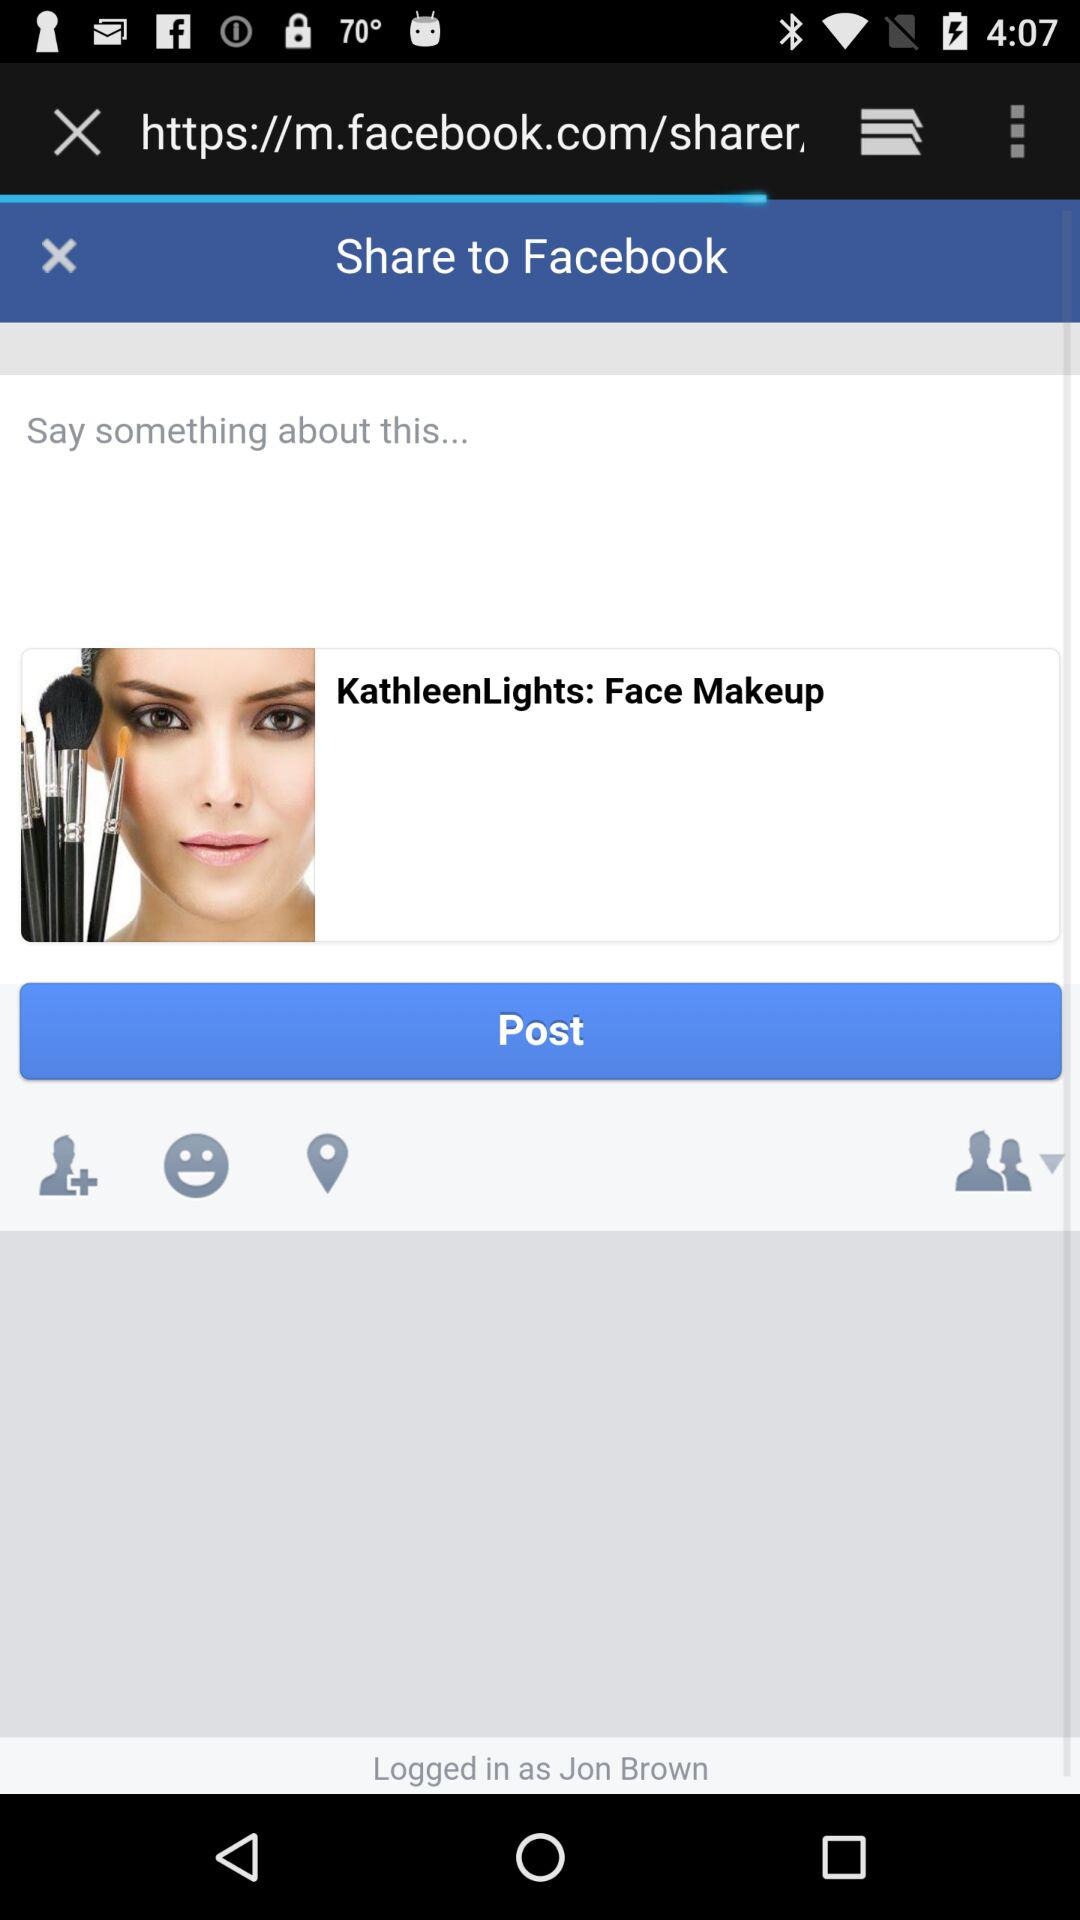What is the user name? The user name is Jon Brown. 